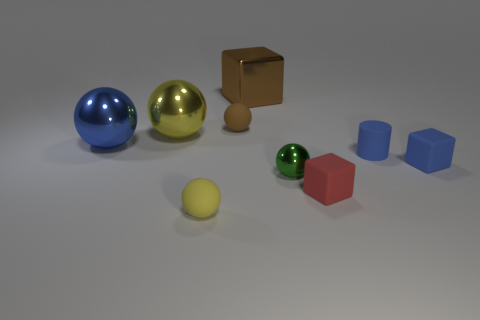Subtract all brown spheres. How many spheres are left? 4 Subtract all big yellow balls. How many balls are left? 4 Subtract all red spheres. Subtract all blue blocks. How many spheres are left? 5 Add 1 gray things. How many objects exist? 10 Subtract all cylinders. How many objects are left? 8 Subtract all big cyan shiny things. Subtract all tiny brown matte spheres. How many objects are left? 8 Add 4 red matte things. How many red matte things are left? 5 Add 8 big blue things. How many big blue things exist? 9 Subtract 0 red spheres. How many objects are left? 9 